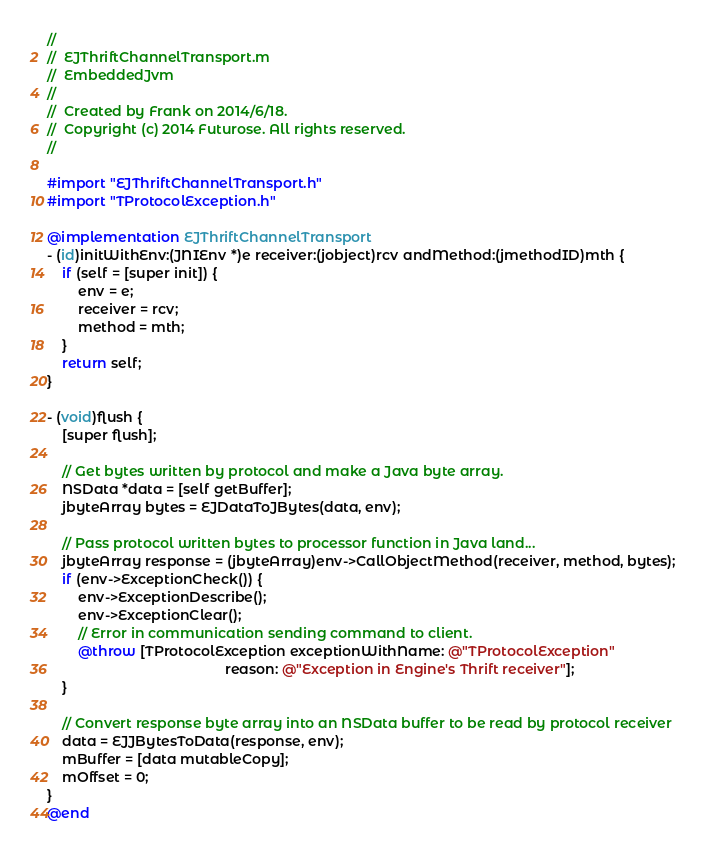<code> <loc_0><loc_0><loc_500><loc_500><_ObjectiveC_>//
//  EJThriftChannelTransport.m
//  EmbeddedJvm
//
//  Created by Frank on 2014/6/18.
//  Copyright (c) 2014 Futurose. All rights reserved.
//

#import "EJThriftChannelTransport.h"
#import "TProtocolException.h"

@implementation EJThriftChannelTransport
- (id)initWithEnv:(JNIEnv *)e receiver:(jobject)rcv andMethod:(jmethodID)mth {
    if (self = [super init]) {
        env = e;
        receiver = rcv;
        method = mth;
    }
    return self;
}

- (void)flush {
    [super flush];
    
    // Get bytes written by protocol and make a Java byte array.
    NSData *data = [self getBuffer];
    jbyteArray bytes = EJDataToJBytes(data, env);
    
    // Pass protocol written bytes to processor function in Java land...
    jbyteArray response = (jbyteArray)env->CallObjectMethod(receiver, method, bytes);
    if (env->ExceptionCheck()) {
        env->ExceptionDescribe();
        env->ExceptionClear();
        // Error in communication sending command to client.
        @throw [TProtocolException exceptionWithName: @"TProtocolException"
                                              reason: @"Exception in Engine's Thrift receiver"];
    }
    
    // Convert response byte array into an NSData buffer to be read by protocol receiver
    data = EJJBytesToData(response, env);
    mBuffer = [data mutableCopy];
    mOffset = 0;
}
@end
</code> 